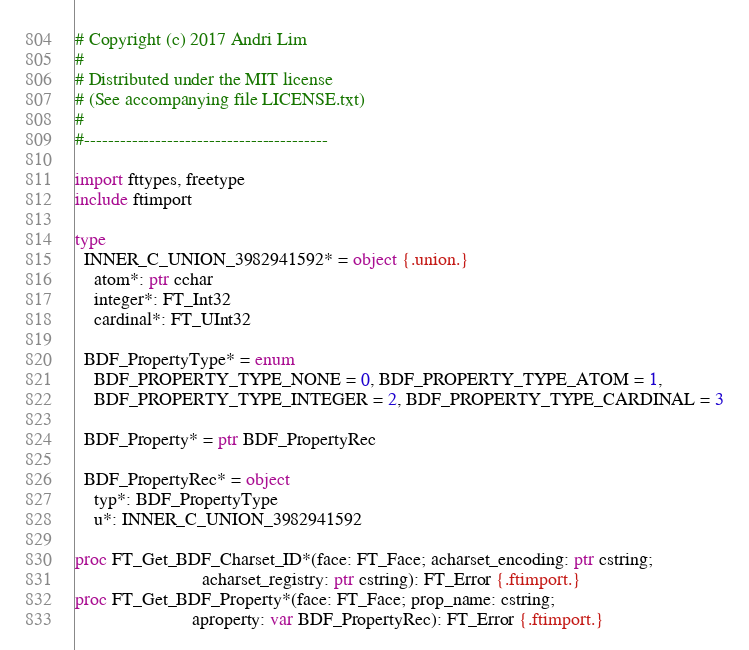<code> <loc_0><loc_0><loc_500><loc_500><_Nim_># Copyright (c) 2017 Andri Lim
#
# Distributed under the MIT license
# (See accompanying file LICENSE.txt)
#
#-----------------------------------------

import fttypes, freetype
include ftimport

type
  INNER_C_UNION_3982941592* = object {.union.}
    atom*: ptr cchar
    integer*: FT_Int32
    cardinal*: FT_UInt32

  BDF_PropertyType* = enum
    BDF_PROPERTY_TYPE_NONE = 0, BDF_PROPERTY_TYPE_ATOM = 1,
    BDF_PROPERTY_TYPE_INTEGER = 2, BDF_PROPERTY_TYPE_CARDINAL = 3

  BDF_Property* = ptr BDF_PropertyRec

  BDF_PropertyRec* = object
    typ*: BDF_PropertyType
    u*: INNER_C_UNION_3982941592

proc FT_Get_BDF_Charset_ID*(face: FT_Face; acharset_encoding: ptr cstring;
                           acharset_registry: ptr cstring): FT_Error {.ftimport.}
proc FT_Get_BDF_Property*(face: FT_Face; prop_name: cstring;
                         aproperty: var BDF_PropertyRec): FT_Error {.ftimport.}
</code> 